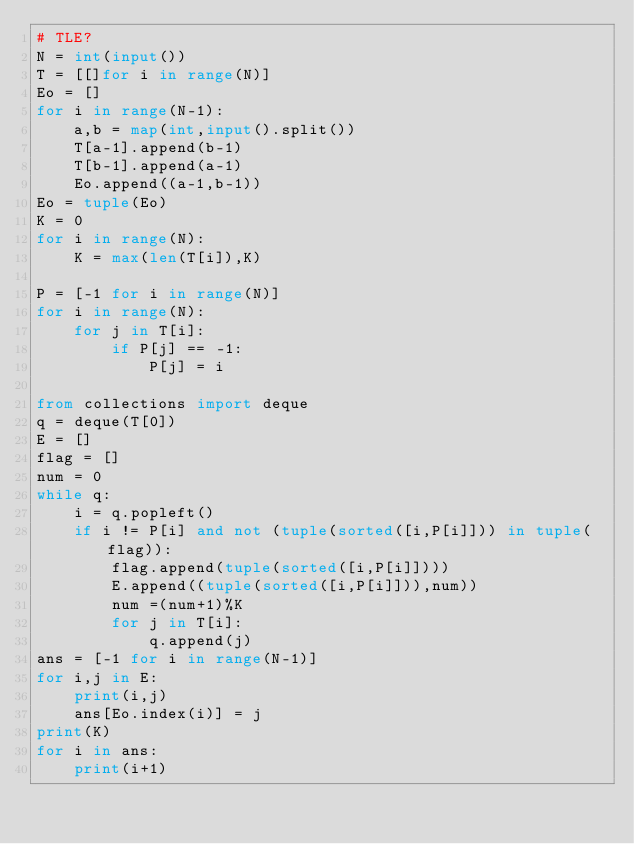Convert code to text. <code><loc_0><loc_0><loc_500><loc_500><_Python_># TLE? 
N = int(input())
T = [[]for i in range(N)]
Eo = []
for i in range(N-1):
    a,b = map(int,input().split())
    T[a-1].append(b-1)
    T[b-1].append(a-1)
    Eo.append((a-1,b-1))
Eo = tuple(Eo)
K = 0
for i in range(N):
    K = max(len(T[i]),K)

P = [-1 for i in range(N)]
for i in range(N):
    for j in T[i]:
        if P[j] == -1:
            P[j] = i

from collections import deque
q = deque(T[0])
E = []
flag = []
num = 0
while q:
    i = q.popleft()
    if i != P[i] and not (tuple(sorted([i,P[i]])) in tuple(flag)):
        flag.append(tuple(sorted([i,P[i]])))
        E.append((tuple(sorted([i,P[i]])),num))
        num =(num+1)%K
        for j in T[i]:
            q.append(j)
ans = [-1 for i in range(N-1)]
for i,j in E:
    print(i,j)
    ans[Eo.index(i)] = j
print(K)
for i in ans:
    print(i+1)</code> 